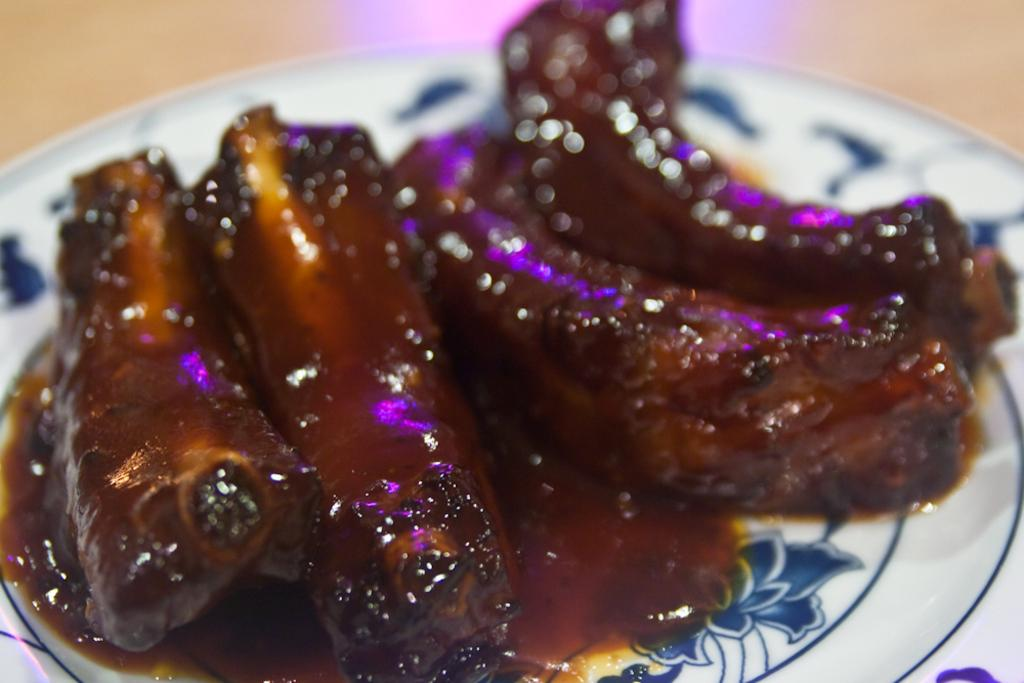What can be seen on the plate in the image? There is food on the plate in the image. Can you describe the type of food on the plate? Unfortunately, the type of food cannot be determined from the provided facts. What type of card is being used to serve the breakfast in the image? There is no mention of a card or breakfast in the image. The image only contains a plate with food on it. 